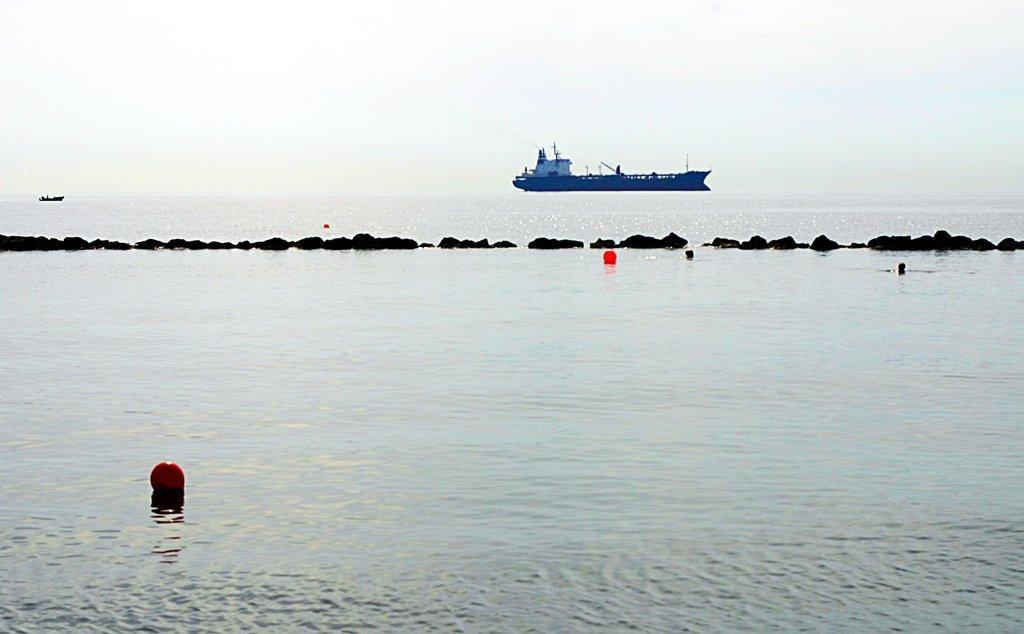Please provide a concise description of this image. In this image we can see some balls floating on the water. We can also see a barrier. On the backside we can some ships in the water. We can also see the sky which looks cloudy. 